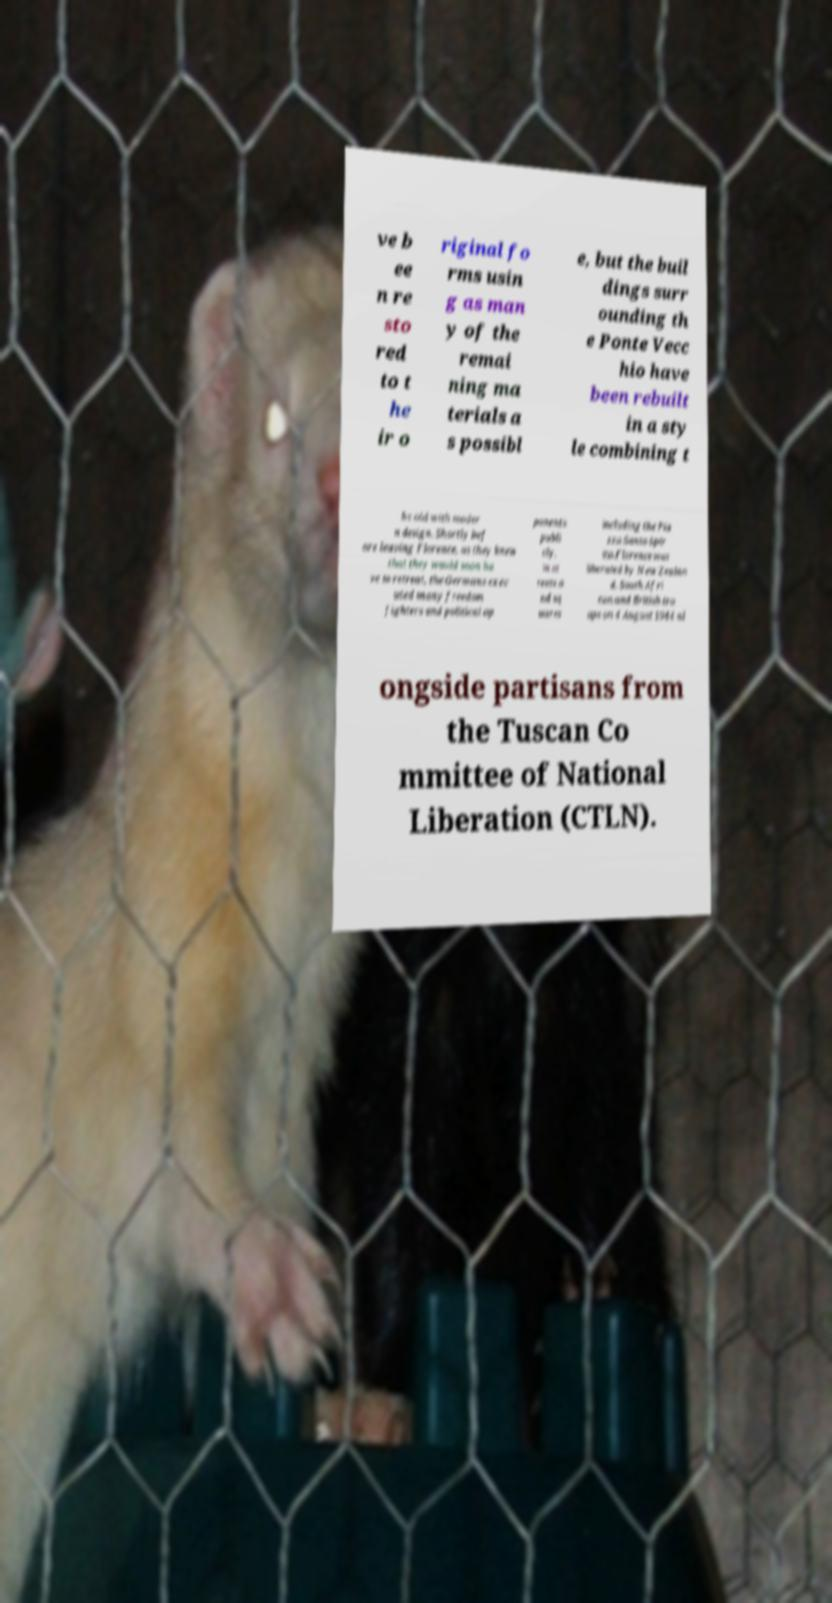Please identify and transcribe the text found in this image. ve b ee n re sto red to t he ir o riginal fo rms usin g as man y of the remai ning ma terials a s possibl e, but the buil dings surr ounding th e Ponte Vecc hio have been rebuilt in a sty le combining t he old with moder n design. Shortly bef ore leaving Florence, as they knew that they would soon ha ve to retreat, the Germans exec uted many freedom fighters and political op ponents publi cly, in st reets a nd sq uares including the Pia zza Santo Spir ito.Florence was liberated by New Zealan d, South Afri can and British tro ops on 4 August 1944 al ongside partisans from the Tuscan Co mmittee of National Liberation (CTLN). 